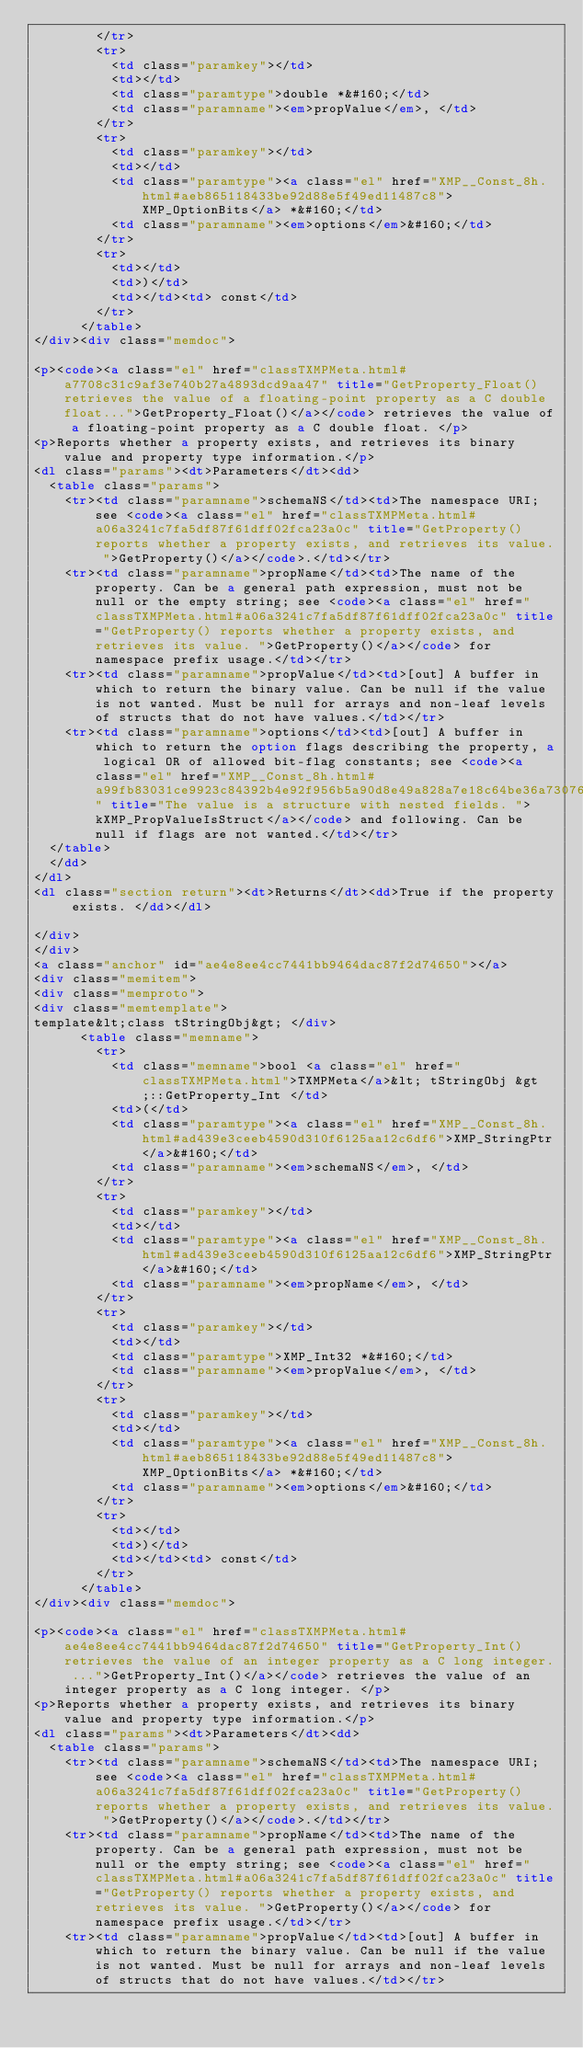Convert code to text. <code><loc_0><loc_0><loc_500><loc_500><_HTML_>        </tr>
        <tr>
          <td class="paramkey"></td>
          <td></td>
          <td class="paramtype">double *&#160;</td>
          <td class="paramname"><em>propValue</em>, </td>
        </tr>
        <tr>
          <td class="paramkey"></td>
          <td></td>
          <td class="paramtype"><a class="el" href="XMP__Const_8h.html#aeb865118433be92d88e5f49ed11487c8">XMP_OptionBits</a> *&#160;</td>
          <td class="paramname"><em>options</em>&#160;</td>
        </tr>
        <tr>
          <td></td>
          <td>)</td>
          <td></td><td> const</td>
        </tr>
      </table>
</div><div class="memdoc">

<p><code><a class="el" href="classTXMPMeta.html#a7708c31c9af3e740b27a4893dcd9aa47" title="GetProperty_Float() retrieves the value of a floating-point property as a C double float...">GetProperty_Float()</a></code> retrieves the value of a floating-point property as a C double float. </p>
<p>Reports whether a property exists, and retrieves its binary value and property type information.</p>
<dl class="params"><dt>Parameters</dt><dd>
  <table class="params">
    <tr><td class="paramname">schemaNS</td><td>The namespace URI; see <code><a class="el" href="classTXMPMeta.html#a06a3241c7fa5df87f61dff02fca23a0c" title="GetProperty() reports whether a property exists, and retrieves its value. ">GetProperty()</a></code>.</td></tr>
    <tr><td class="paramname">propName</td><td>The name of the property. Can be a general path expression, must not be null or the empty string; see <code><a class="el" href="classTXMPMeta.html#a06a3241c7fa5df87f61dff02fca23a0c" title="GetProperty() reports whether a property exists, and retrieves its value. ">GetProperty()</a></code> for namespace prefix usage.</td></tr>
    <tr><td class="paramname">propValue</td><td>[out] A buffer in which to return the binary value. Can be null if the value is not wanted. Must be null for arrays and non-leaf levels of structs that do not have values.</td></tr>
    <tr><td class="paramname">options</td><td>[out] A buffer in which to return the option flags describing the property, a logical OR of allowed bit-flag constants; see <code><a class="el" href="XMP__Const_8h.html#a99fb83031ce9923c84392b4e92f956b5a90d8e49a828a7e18c64be36a73076a7e" title="The value is a structure with nested fields. ">kXMP_PropValueIsStruct</a></code> and following. Can be null if flags are not wanted.</td></tr>
  </table>
  </dd>
</dl>
<dl class="section return"><dt>Returns</dt><dd>True if the property exists. </dd></dl>

</div>
</div>
<a class="anchor" id="ae4e8ee4cc7441bb9464dac87f2d74650"></a>
<div class="memitem">
<div class="memproto">
<div class="memtemplate">
template&lt;class tStringObj&gt; </div>
      <table class="memname">
        <tr>
          <td class="memname">bool <a class="el" href="classTXMPMeta.html">TXMPMeta</a>&lt; tStringObj &gt;::GetProperty_Int </td>
          <td>(</td>
          <td class="paramtype"><a class="el" href="XMP__Const_8h.html#ad439e3ceeb4590d310f6125aa12c6df6">XMP_StringPtr</a>&#160;</td>
          <td class="paramname"><em>schemaNS</em>, </td>
        </tr>
        <tr>
          <td class="paramkey"></td>
          <td></td>
          <td class="paramtype"><a class="el" href="XMP__Const_8h.html#ad439e3ceeb4590d310f6125aa12c6df6">XMP_StringPtr</a>&#160;</td>
          <td class="paramname"><em>propName</em>, </td>
        </tr>
        <tr>
          <td class="paramkey"></td>
          <td></td>
          <td class="paramtype">XMP_Int32 *&#160;</td>
          <td class="paramname"><em>propValue</em>, </td>
        </tr>
        <tr>
          <td class="paramkey"></td>
          <td></td>
          <td class="paramtype"><a class="el" href="XMP__Const_8h.html#aeb865118433be92d88e5f49ed11487c8">XMP_OptionBits</a> *&#160;</td>
          <td class="paramname"><em>options</em>&#160;</td>
        </tr>
        <tr>
          <td></td>
          <td>)</td>
          <td></td><td> const</td>
        </tr>
      </table>
</div><div class="memdoc">

<p><code><a class="el" href="classTXMPMeta.html#ae4e8ee4cc7441bb9464dac87f2d74650" title="GetProperty_Int() retrieves the value of an integer property as a C long integer. ...">GetProperty_Int()</a></code> retrieves the value of an integer property as a C long integer. </p>
<p>Reports whether a property exists, and retrieves its binary value and property type information.</p>
<dl class="params"><dt>Parameters</dt><dd>
  <table class="params">
    <tr><td class="paramname">schemaNS</td><td>The namespace URI; see <code><a class="el" href="classTXMPMeta.html#a06a3241c7fa5df87f61dff02fca23a0c" title="GetProperty() reports whether a property exists, and retrieves its value. ">GetProperty()</a></code>.</td></tr>
    <tr><td class="paramname">propName</td><td>The name of the property. Can be a general path expression, must not be null or the empty string; see <code><a class="el" href="classTXMPMeta.html#a06a3241c7fa5df87f61dff02fca23a0c" title="GetProperty() reports whether a property exists, and retrieves its value. ">GetProperty()</a></code> for namespace prefix usage.</td></tr>
    <tr><td class="paramname">propValue</td><td>[out] A buffer in which to return the binary value. Can be null if the value is not wanted. Must be null for arrays and non-leaf levels of structs that do not have values.</td></tr></code> 